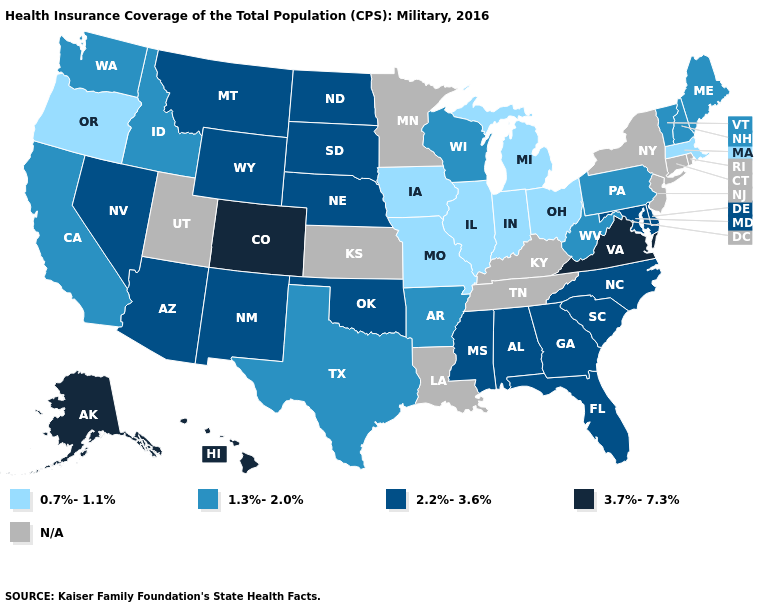Among the states that border Tennessee , does Missouri have the lowest value?
Give a very brief answer. Yes. Name the states that have a value in the range 0.7%-1.1%?
Write a very short answer. Illinois, Indiana, Iowa, Massachusetts, Michigan, Missouri, Ohio, Oregon. Does Maine have the lowest value in the Northeast?
Answer briefly. No. What is the value of Indiana?
Quick response, please. 0.7%-1.1%. Does the map have missing data?
Concise answer only. Yes. Name the states that have a value in the range 1.3%-2.0%?
Answer briefly. Arkansas, California, Idaho, Maine, New Hampshire, Pennsylvania, Texas, Vermont, Washington, West Virginia, Wisconsin. Name the states that have a value in the range 0.7%-1.1%?
Short answer required. Illinois, Indiana, Iowa, Massachusetts, Michigan, Missouri, Ohio, Oregon. Name the states that have a value in the range 2.2%-3.6%?
Be succinct. Alabama, Arizona, Delaware, Florida, Georgia, Maryland, Mississippi, Montana, Nebraska, Nevada, New Mexico, North Carolina, North Dakota, Oklahoma, South Carolina, South Dakota, Wyoming. What is the value of Alaska?
Be succinct. 3.7%-7.3%. Does the first symbol in the legend represent the smallest category?
Concise answer only. Yes. What is the highest value in states that border Tennessee?
Give a very brief answer. 3.7%-7.3%. What is the lowest value in the West?
Give a very brief answer. 0.7%-1.1%. Name the states that have a value in the range 1.3%-2.0%?
Write a very short answer. Arkansas, California, Idaho, Maine, New Hampshire, Pennsylvania, Texas, Vermont, Washington, West Virginia, Wisconsin. 